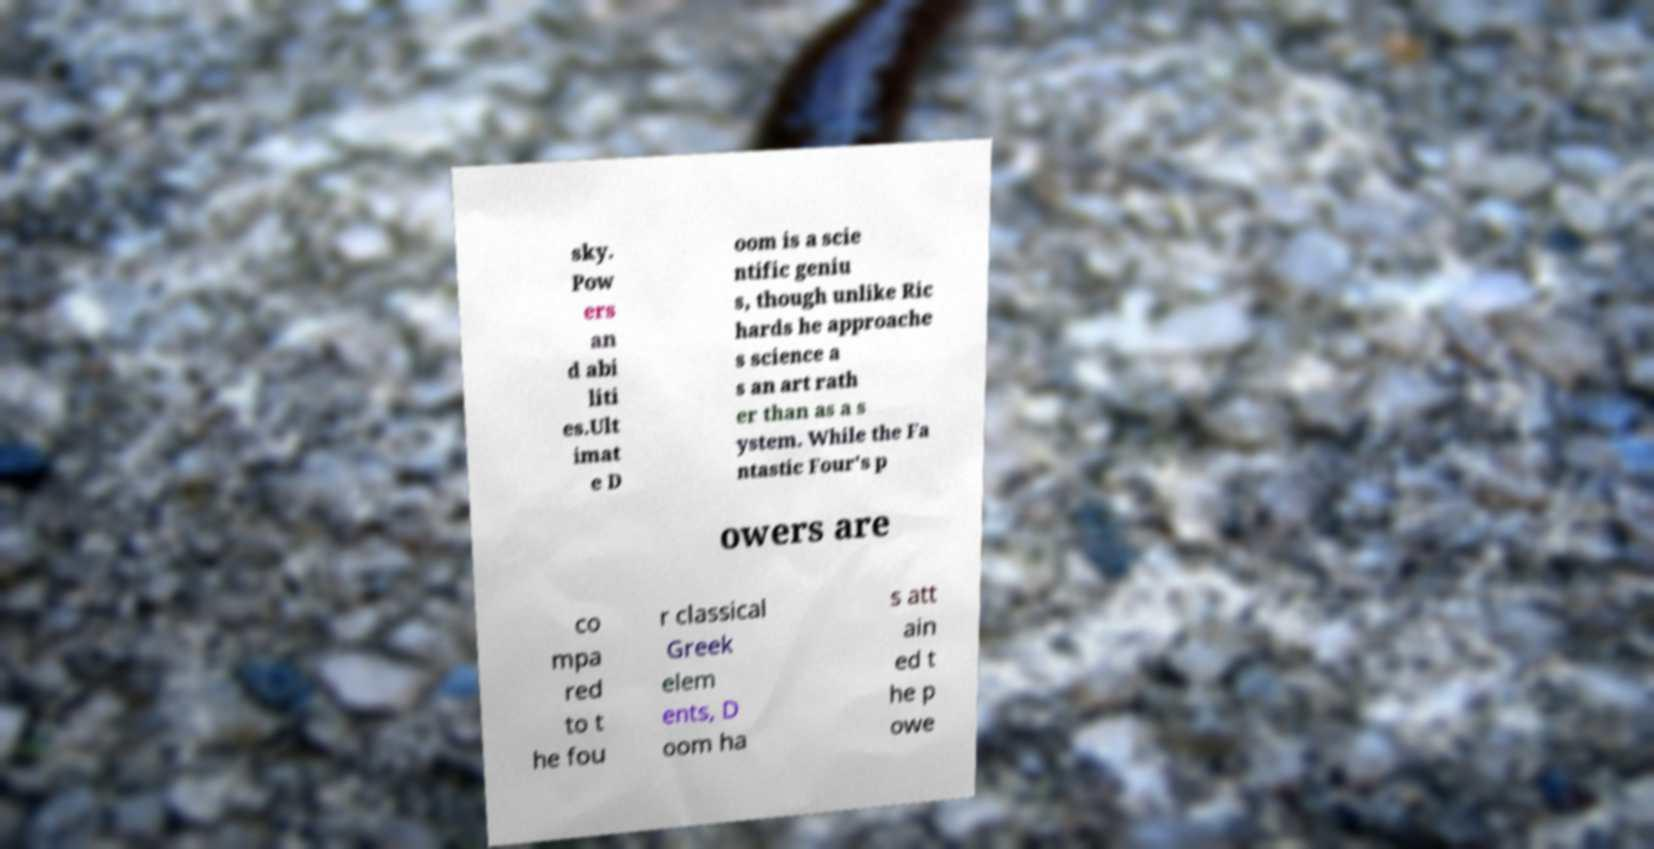Can you read and provide the text displayed in the image?This photo seems to have some interesting text. Can you extract and type it out for me? sky. Pow ers an d abi liti es.Ult imat e D oom is a scie ntific geniu s, though unlike Ric hards he approache s science a s an art rath er than as a s ystem. While the Fa ntastic Four's p owers are co mpa red to t he fou r classical Greek elem ents, D oom ha s att ain ed t he p owe 